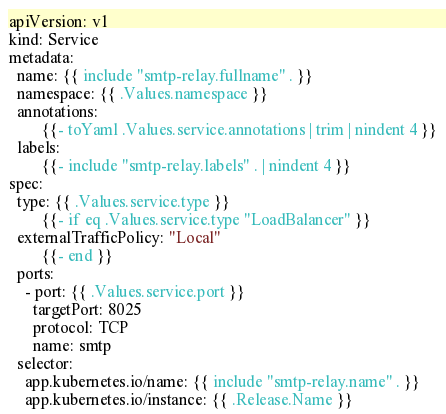Convert code to text. <code><loc_0><loc_0><loc_500><loc_500><_YAML_>apiVersion: v1
kind: Service
metadata:
  name: {{ include "smtp-relay.fullname" . }}
  namespace: {{ .Values.namespace }}
  annotations:
        {{- toYaml .Values.service.annotations | trim | nindent 4 }}
  labels:
        {{- include "smtp-relay.labels" . | nindent 4 }}
spec:
  type: {{ .Values.service.type }}
        {{- if eq .Values.service.type "LoadBalancer" }}
  externalTrafficPolicy: "Local"
        {{- end }}
  ports:
    - port: {{ .Values.service.port }}
      targetPort: 8025
      protocol: TCP
      name: smtp
  selector:
    app.kubernetes.io/name: {{ include "smtp-relay.name" . }}
    app.kubernetes.io/instance: {{ .Release.Name }}
</code> 